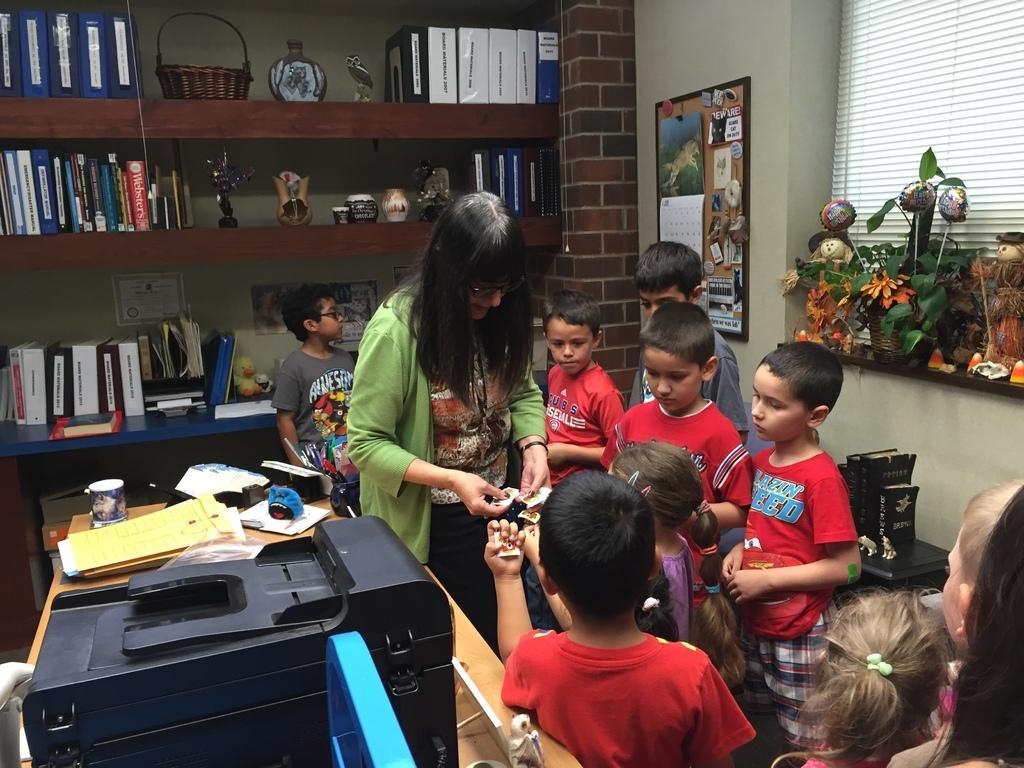Could you give a brief overview of what you see in this image? There is a lady with green jacket is standing. And she is giving something to the children. There are some children with red t-shirt are standing. In background there is a wall with some board on it. To right of corner there is a window and some plants. In the background there some books in the cupboard. We can see a basket. In top bottom corner there is a printer and files on the table. 